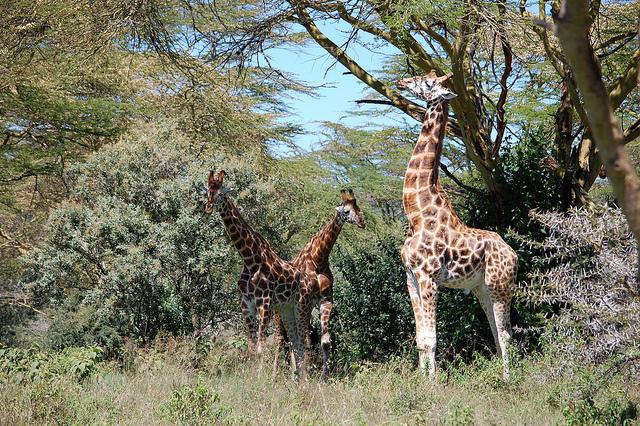How many giraffes are there?
Short answer required. 3. What is the weather like?
Give a very brief answer. Sunny. Are the giraffes in a museum?
Be succinct. No. Why are the giraffes all grouped together in the corner?
Short answer required. Eating. What are the giraffes doing?
Quick response, please. Eating. What are these animals made of?
Give a very brief answer. Bones. 